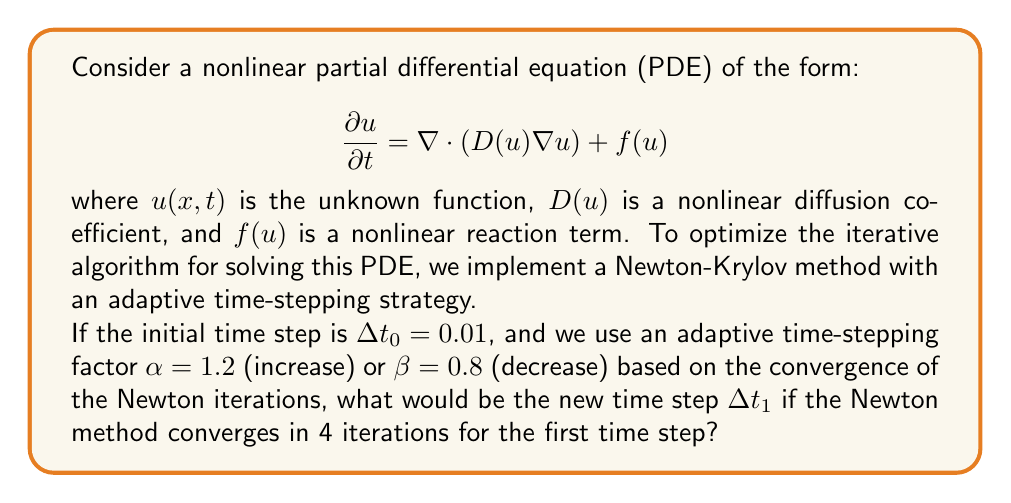Help me with this question. To optimize the iterative algorithm for solving nonlinear PDEs, we often use adaptive time-stepping strategies. This approach allows us to increase the time step when the solution is smooth and decrease it when the solution changes rapidly.

Let's break down the problem and solve it step-by-step:

1) We start with an initial time step $\Delta t_0 = 0.01$.

2) The adaptive time-stepping strategy typically works as follows:
   - If the Newton method converges quickly (usually in fewer iterations than a set threshold), we increase the time step.
   - If the Newton method converges slowly or fails to converge, we decrease the time step.

3) In this case, we're told that:
   - The increase factor is $\alpha = 1.2$
   - The decrease factor is $\beta = 0.8$
   - The Newton method converged in 4 iterations

4) Usually, we set a threshold for the number of iterations. Let's assume that our threshold is 5 iterations. Since the method converged in 4 iterations, which is less than our threshold, we will increase the time step.

5) To calculate the new time step, we multiply the current time step by the increase factor:

   $$\Delta t_1 = \alpha \cdot \Delta t_0$$

6) Substituting the values:

   $$\Delta t_1 = 1.2 \cdot 0.01 = 0.012$$

Therefore, the new time step $\Delta t_1$ will be 0.012.
Answer: $\Delta t_1 = 0.012$ 